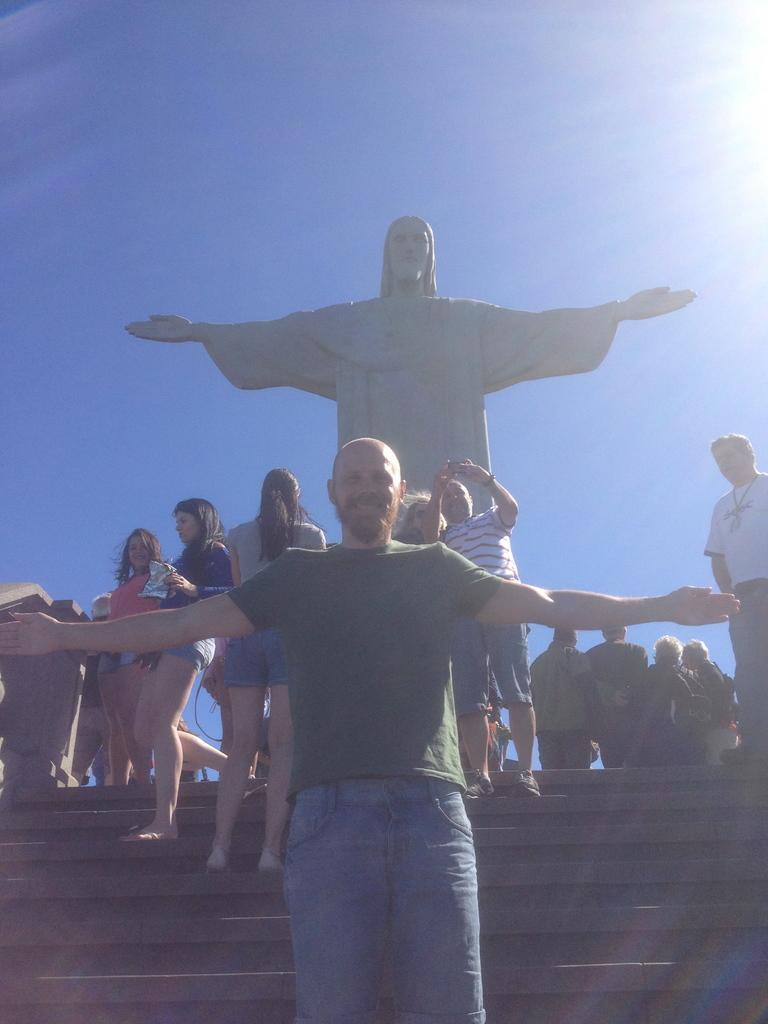Could you give a brief overview of what you see in this image? In this image we can see many people, and some of them are standing on the stairs and in the background we can see a Christ Redeemer statue and the sky. 